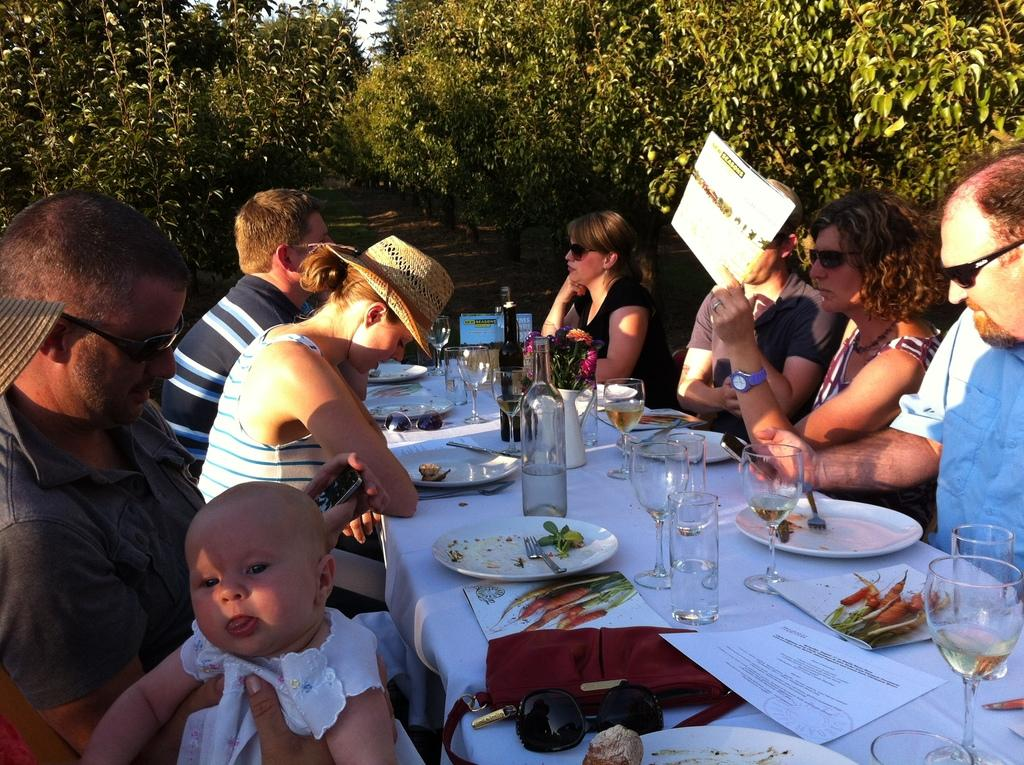What type of vegetation can be seen in the image? There are trees in the image. What are the people in the image doing? There are persons sitting on chairs in the image. What items can be seen on the table in the image? There are bottles, glasses, papers, and plates on the table in the image. What is the woman holding in the image? A woman is holding a card in the image. What type of breakfast is being served in the image? There is no breakfast visible in the image. What event is taking place in the image? The image does not depict a specific event; it shows people sitting on chairs, a woman holding a card, and items on a table. 